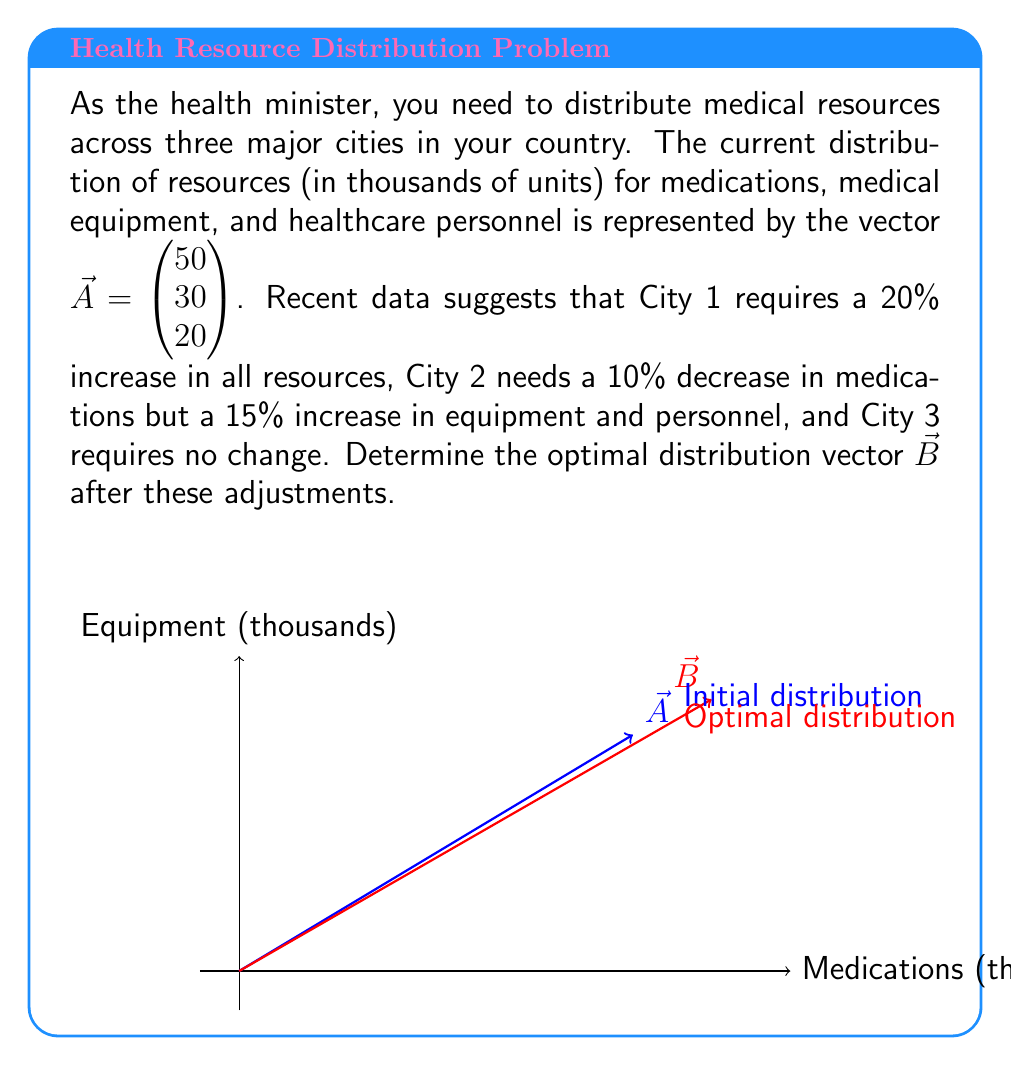Show me your answer to this math problem. Let's approach this step-by-step:

1) First, we need to create adjustment vectors for each city:

   City 1: $\vec{C_1} = \begin{pmatrix} 1.2 \\ 1.2 \\ 1.2 \end{pmatrix}$ (20% increase in all resources)
   City 2: $\vec{C_2} = \begin{pmatrix} 0.9 \\ 1.15 \\ 1.15 \end{pmatrix}$ (10% decrease in medications, 15% increase in equipment and personnel)
   City 3: $\vec{C_3} = \begin{pmatrix} 1 \\ 1 \\ 1 \end{pmatrix}$ (no change)

2) Now, we need to apply these adjustments to the original distribution vector $\vec{A}$:

   $\vec{B} = \frac{1}{3}(\vec{C_1} \odot \vec{A} + \vec{C_2} \odot \vec{A} + \vec{C_3} \odot \vec{A})$

   Where $\odot$ represents element-wise multiplication.

3) Let's calculate each term:

   $\vec{C_1} \odot \vec{A} = \begin{pmatrix} 1.2 \cdot 50 \\ 1.2 \cdot 30 \\ 1.2 \cdot 20 \end{pmatrix} = \begin{pmatrix} 60 \\ 36 \\ 24 \end{pmatrix}$

   $\vec{C_2} \odot \vec{A} = \begin{pmatrix} 0.9 \cdot 50 \\ 1.15 \cdot 30 \\ 1.15 \cdot 20 \end{pmatrix} = \begin{pmatrix} 45 \\ 34.5 \\ 23 \end{pmatrix}$

   $\vec{C_3} \odot \vec{A} = \begin{pmatrix} 1 \cdot 50 \\ 1 \cdot 30 \\ 1 \cdot 20 \end{pmatrix} = \begin{pmatrix} 50 \\ 30 \\ 20 \end{pmatrix}$

4) Now, we sum these vectors and multiply by $\frac{1}{3}$:

   $\vec{B} = \frac{1}{3}\begin{pmatrix} 60 + 45 + 50 \\ 36 + 34.5 + 30 \\ 24 + 23 + 20 \end{pmatrix} = \frac{1}{3}\begin{pmatrix} 155 \\ 100.5 \\ 67 \end{pmatrix}$

5) Simplifying:

   $\vec{B} = \begin{pmatrix} 51.67 \\ 33.5 \\ 22.33 \end{pmatrix}$

This vector represents the optimal distribution of resources (in thousands of units) for medications, medical equipment, and healthcare personnel respectively.
Answer: $\vec{B} = \begin{pmatrix} 51.67 \\ 33.5 \\ 22.33 \end{pmatrix}$ 